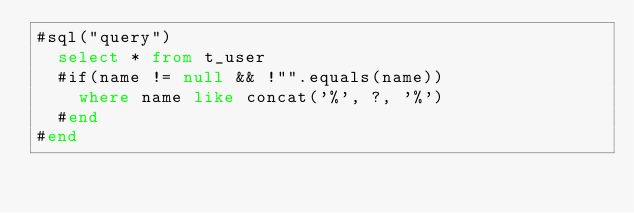Convert code to text. <code><loc_0><loc_0><loc_500><loc_500><_SQL_>#sql("query")
  select * from t_user
  #if(name != null && !"".equals(name))
    where name like concat('%', ?, '%')
  #end
#end
</code> 